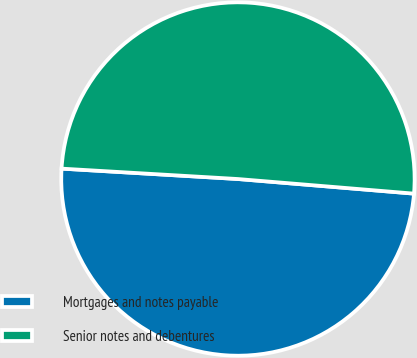Convert chart to OTSL. <chart><loc_0><loc_0><loc_500><loc_500><pie_chart><fcel>Mortgages and notes payable<fcel>Senior notes and debentures<nl><fcel>49.62%<fcel>50.38%<nl></chart> 